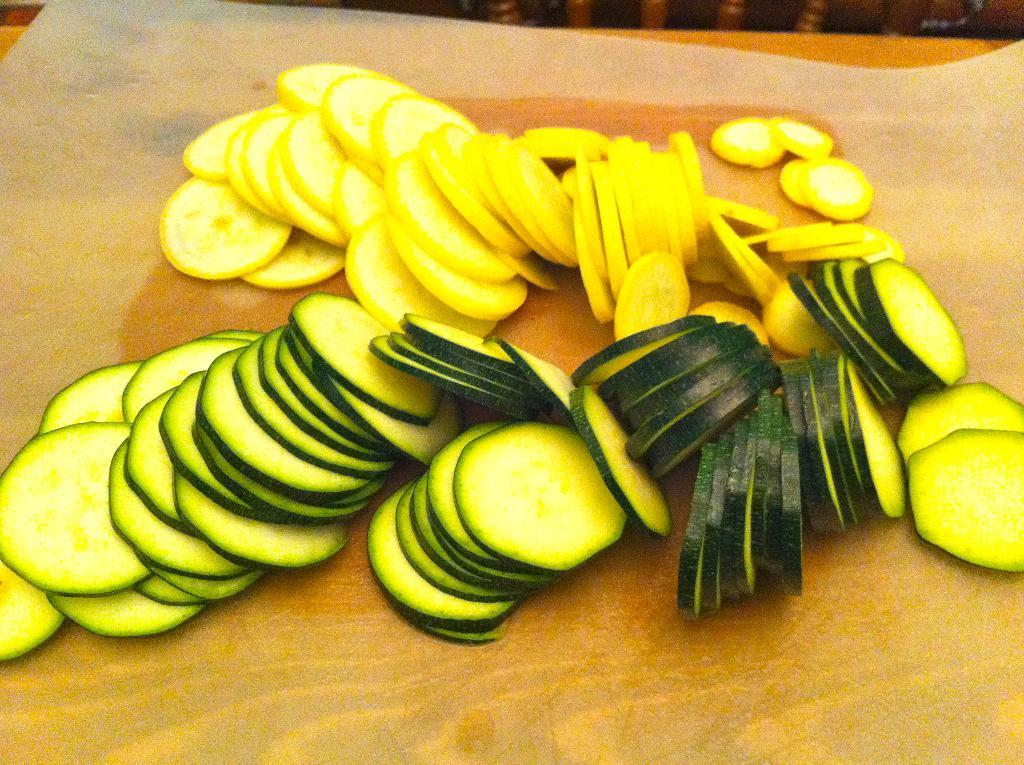What type of food can be seen in the image? There are sliced vegetables in the image. Where are the sliced vegetables located? The sliced vegetables are on a surface. What type of brush is used to clean the vegetables in the image? There is no brush present in the image, and the vegetables are not being cleaned. 